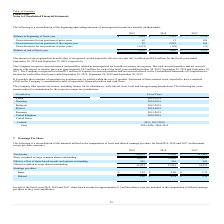From Plexus's financial document, Which years does the table provide information for the amounts utilized in the computation of basic and diluted earnings per share? The document contains multiple relevant values: 2019, 2018, 2017. From the document: "2019 2018 2017 2019 2018 2017 2019 2018 2017..." Also, What was the amount of net income in 2017? According to the financial document, 112,062 (in thousands). The relevant text states: "Net income $ 108,616 $ 13,040 $ 112,062..." Also, What was the amount of basic earnings per share in 2019? According to the financial document, 3.59. The relevant text states: "Basic $ 3.59 $ 0.40 $ 3.33..." Also, How many years did net income exceed $100,000 thousand? Counting the relevant items in the document: 2019, 2017, I find 2 instances. The key data points involved are: 2017, 2019. Also, can you calculate: What was the change in the Basic weighted average common shares outstanding between 2018 and 2019? Based on the calculation: 30,271-33,612, the result is -3341 (in thousands). This is based on the information: "Basic weighted average common shares outstanding 30,271 33,003 33,612 d average common shares outstanding 30,271 33,003 33,612..." The key data points involved are: 30,271, 33,612. Also, can you calculate: What was the percentage change in the diluted earnings per share between 2017 and 2019? To answer this question, I need to perform calculations using the financial data. The calculation is: (3.50-3.24)/3.24, which equals 8.02 (percentage). This is based on the information: "Diluted $ 3.50 $ 0.38 $ 3.24 Diluted $ 3.50 $ 0.38 $ 3.24..." The key data points involved are: 3.24, 3.50. 